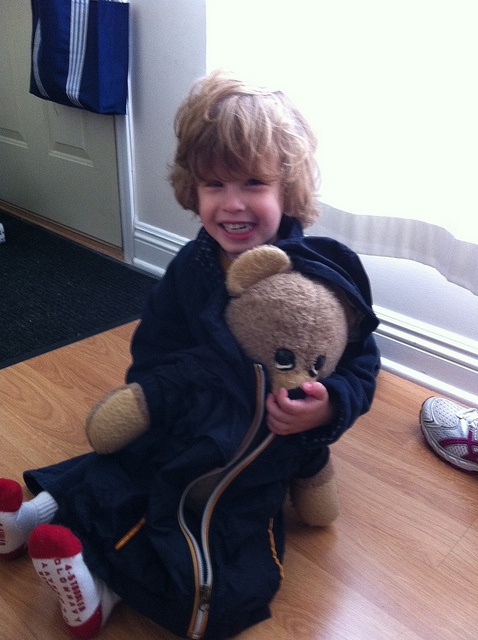Describe the objects in this image and their specific colors. I can see people in gray, black, and maroon tones, teddy bear in gray, black, and darkgray tones, and handbag in gray, navy, and black tones in this image. 